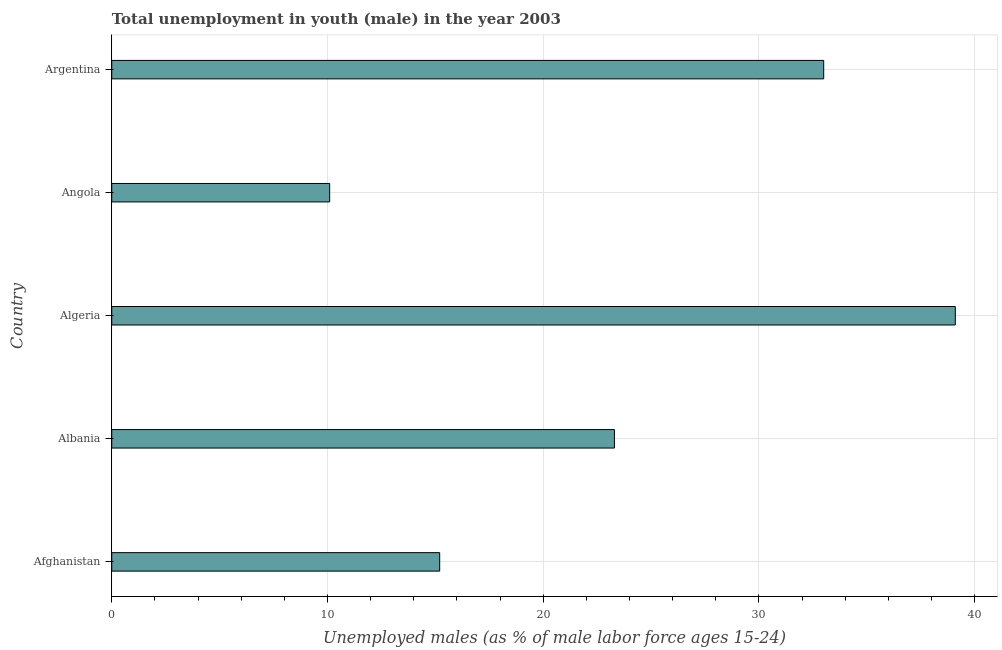Does the graph contain any zero values?
Your response must be concise. No. Does the graph contain grids?
Provide a short and direct response. Yes. What is the title of the graph?
Ensure brevity in your answer.  Total unemployment in youth (male) in the year 2003. What is the label or title of the X-axis?
Provide a short and direct response. Unemployed males (as % of male labor force ages 15-24). What is the label or title of the Y-axis?
Provide a succinct answer. Country. What is the unemployed male youth population in Algeria?
Offer a terse response. 39.1. Across all countries, what is the maximum unemployed male youth population?
Make the answer very short. 39.1. Across all countries, what is the minimum unemployed male youth population?
Your response must be concise. 10.1. In which country was the unemployed male youth population maximum?
Provide a succinct answer. Algeria. In which country was the unemployed male youth population minimum?
Provide a short and direct response. Angola. What is the sum of the unemployed male youth population?
Offer a terse response. 120.7. What is the difference between the unemployed male youth population in Algeria and Argentina?
Give a very brief answer. 6.1. What is the average unemployed male youth population per country?
Your answer should be very brief. 24.14. What is the median unemployed male youth population?
Provide a short and direct response. 23.3. What is the ratio of the unemployed male youth population in Albania to that in Angola?
Give a very brief answer. 2.31. Is the unemployed male youth population in Afghanistan less than that in Angola?
Your answer should be compact. No. How many bars are there?
Offer a very short reply. 5. Are all the bars in the graph horizontal?
Make the answer very short. Yes. What is the difference between two consecutive major ticks on the X-axis?
Your answer should be compact. 10. Are the values on the major ticks of X-axis written in scientific E-notation?
Offer a very short reply. No. What is the Unemployed males (as % of male labor force ages 15-24) in Afghanistan?
Provide a succinct answer. 15.2. What is the Unemployed males (as % of male labor force ages 15-24) of Albania?
Offer a very short reply. 23.3. What is the Unemployed males (as % of male labor force ages 15-24) in Algeria?
Your answer should be compact. 39.1. What is the Unemployed males (as % of male labor force ages 15-24) of Angola?
Your response must be concise. 10.1. What is the difference between the Unemployed males (as % of male labor force ages 15-24) in Afghanistan and Algeria?
Provide a succinct answer. -23.9. What is the difference between the Unemployed males (as % of male labor force ages 15-24) in Afghanistan and Angola?
Your answer should be very brief. 5.1. What is the difference between the Unemployed males (as % of male labor force ages 15-24) in Afghanistan and Argentina?
Ensure brevity in your answer.  -17.8. What is the difference between the Unemployed males (as % of male labor force ages 15-24) in Albania and Algeria?
Make the answer very short. -15.8. What is the difference between the Unemployed males (as % of male labor force ages 15-24) in Albania and Argentina?
Your answer should be compact. -9.7. What is the difference between the Unemployed males (as % of male labor force ages 15-24) in Algeria and Argentina?
Offer a terse response. 6.1. What is the difference between the Unemployed males (as % of male labor force ages 15-24) in Angola and Argentina?
Provide a succinct answer. -22.9. What is the ratio of the Unemployed males (as % of male labor force ages 15-24) in Afghanistan to that in Albania?
Your answer should be compact. 0.65. What is the ratio of the Unemployed males (as % of male labor force ages 15-24) in Afghanistan to that in Algeria?
Make the answer very short. 0.39. What is the ratio of the Unemployed males (as % of male labor force ages 15-24) in Afghanistan to that in Angola?
Ensure brevity in your answer.  1.5. What is the ratio of the Unemployed males (as % of male labor force ages 15-24) in Afghanistan to that in Argentina?
Ensure brevity in your answer.  0.46. What is the ratio of the Unemployed males (as % of male labor force ages 15-24) in Albania to that in Algeria?
Provide a succinct answer. 0.6. What is the ratio of the Unemployed males (as % of male labor force ages 15-24) in Albania to that in Angola?
Your answer should be very brief. 2.31. What is the ratio of the Unemployed males (as % of male labor force ages 15-24) in Albania to that in Argentina?
Your response must be concise. 0.71. What is the ratio of the Unemployed males (as % of male labor force ages 15-24) in Algeria to that in Angola?
Keep it short and to the point. 3.87. What is the ratio of the Unemployed males (as % of male labor force ages 15-24) in Algeria to that in Argentina?
Keep it short and to the point. 1.19. What is the ratio of the Unemployed males (as % of male labor force ages 15-24) in Angola to that in Argentina?
Ensure brevity in your answer.  0.31. 